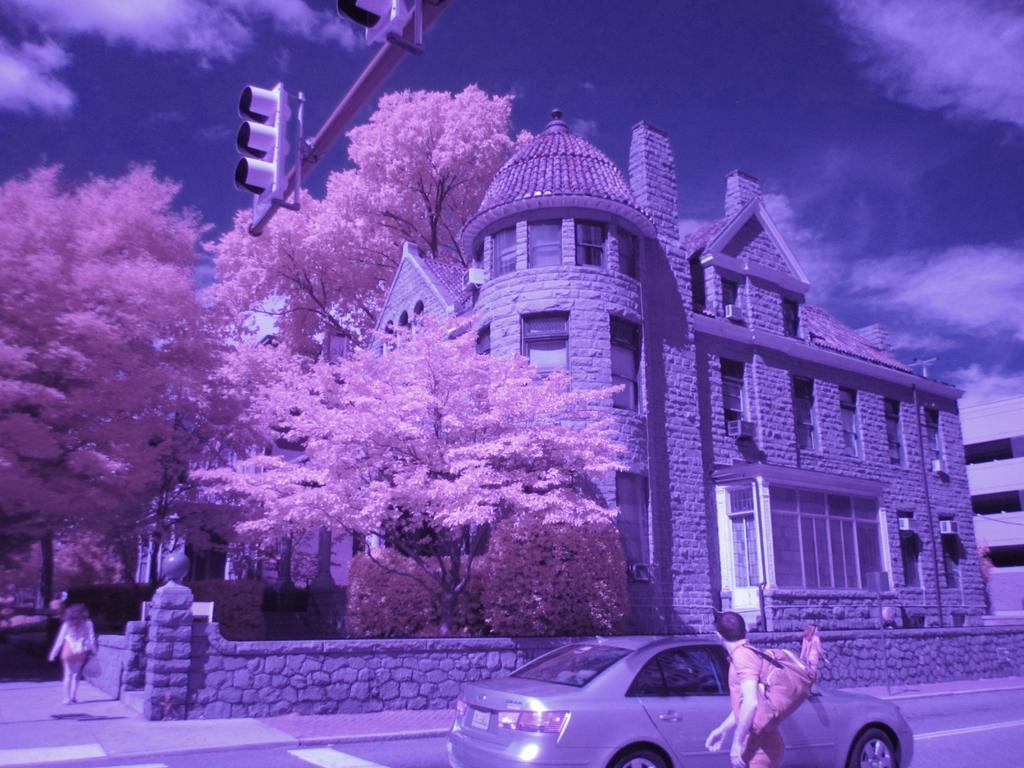Please provide a concise description of this image. In this picture there are trees on the left side of the image and there is a palace in the center of the image, there is a car in the center of the image and there is a traffic pole at the top side of the image, there is a man on the right side of the image and there is lady on the left side. 